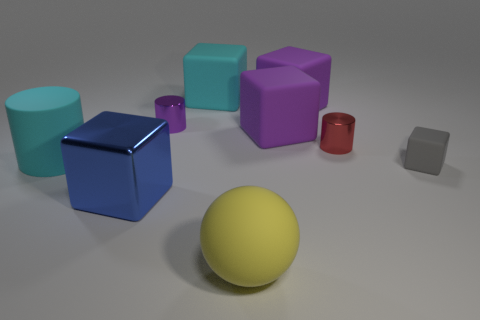Subtract all blue balls. How many purple cubes are left? 2 Subtract all purple rubber blocks. How many blocks are left? 3 Add 1 large cyan matte things. How many objects exist? 10 Subtract all purple blocks. How many blocks are left? 3 Subtract all brown blocks. Subtract all purple balls. How many blocks are left? 5 Add 4 large yellow rubber cylinders. How many large yellow rubber cylinders exist? 4 Subtract 2 purple cubes. How many objects are left? 7 Subtract all spheres. How many objects are left? 8 Subtract all tiny green balls. Subtract all big cyan cylinders. How many objects are left? 8 Add 8 cyan rubber objects. How many cyan rubber objects are left? 10 